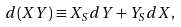Convert formula to latex. <formula><loc_0><loc_0><loc_500><loc_500>d ( X Y ) \equiv X _ { S } d Y + Y _ { S } d X ,</formula> 